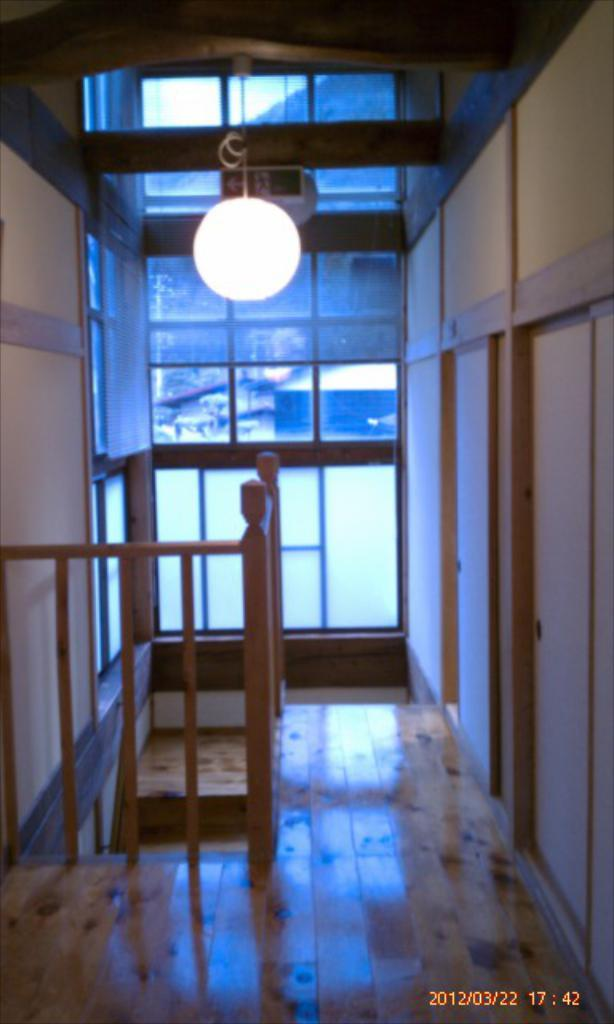What type of architectural feature can be seen in the image? There are doors and a staircase in the image. What type of barrier is present in the image? There is fencing in the image. Where is the lamp located in the image? The lamp is on the roof in the image. What type of receipt can be seen hanging from the doors in the image? There is no receipt present in the image; it features doors, a staircase, fencing, and a lamp on the roof. What type of stem is visible on the staircase in the image? There is no stem present on the staircase in the image. 